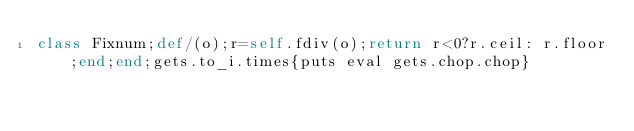Convert code to text. <code><loc_0><loc_0><loc_500><loc_500><_Ruby_>class Fixnum;def/(o);r=self.fdiv(o);return r<0?r.ceil: r.floor;end;end;gets.to_i.times{puts eval gets.chop.chop}</code> 